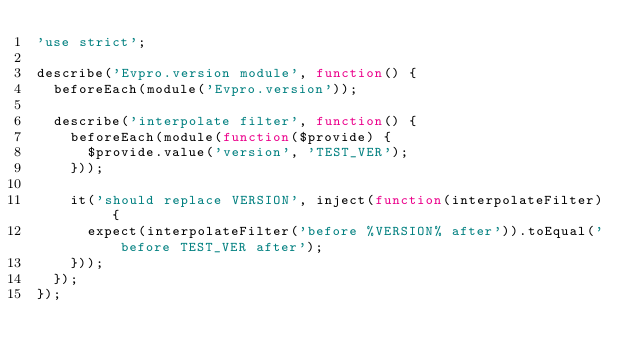<code> <loc_0><loc_0><loc_500><loc_500><_JavaScript_>'use strict';

describe('Evpro.version module', function() {
  beforeEach(module('Evpro.version'));

  describe('interpolate filter', function() {
    beforeEach(module(function($provide) {
      $provide.value('version', 'TEST_VER');
    }));

    it('should replace VERSION', inject(function(interpolateFilter) {
      expect(interpolateFilter('before %VERSION% after')).toEqual('before TEST_VER after');
    }));
  });
});
</code> 